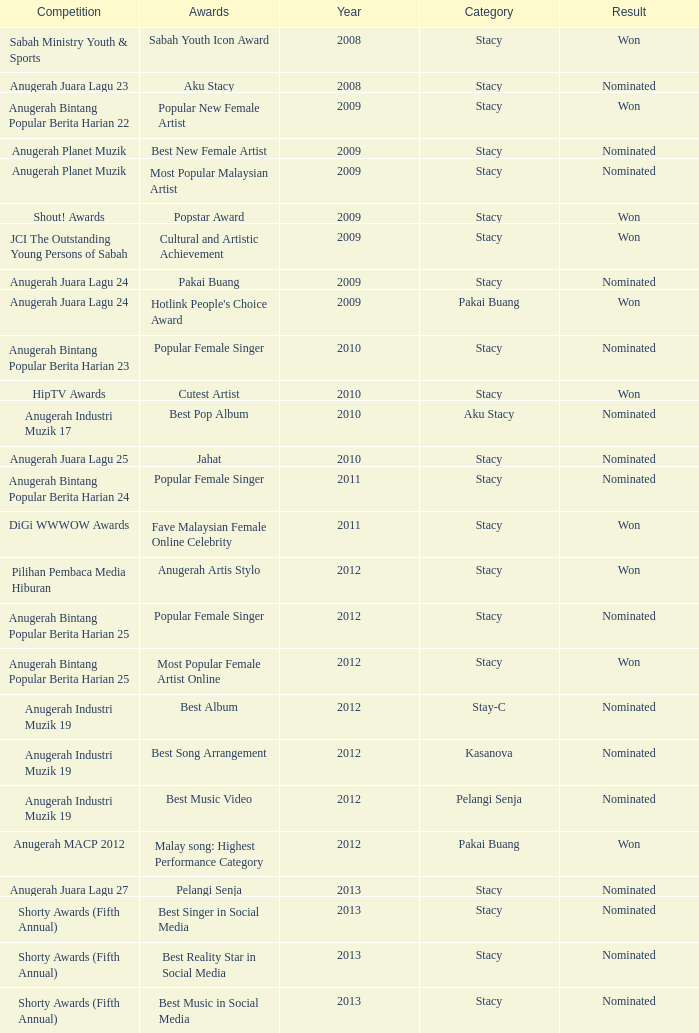What was the result in the year greaters than 2008 with an award of Jahat and had a category of Stacy? Nominated. 